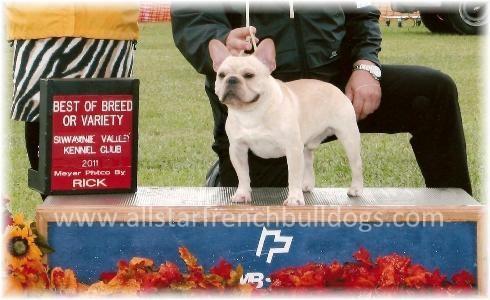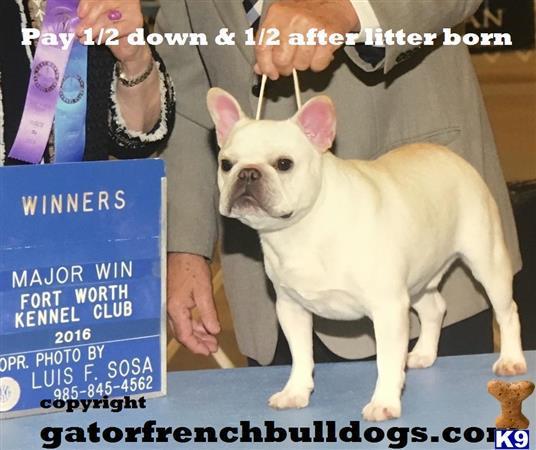The first image is the image on the left, the second image is the image on the right. Evaluate the accuracy of this statement regarding the images: "Two French Bulldogs are being held on a leash by a human.". Is it true? Answer yes or no. Yes. 